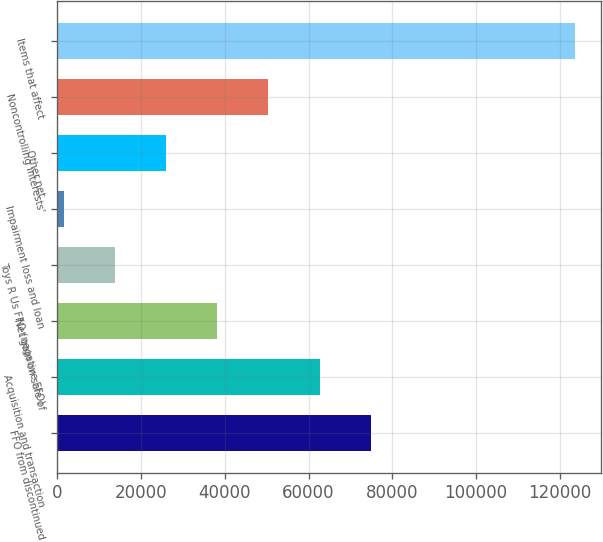Convert chart to OTSL. <chart><loc_0><loc_0><loc_500><loc_500><bar_chart><fcel>FFO from discontinued<fcel>Acquisition and transaction<fcel>Net gain on sale of<fcel>Toys R Us FFO (negative FFO)<fcel>Impairment loss and loan<fcel>Other net<fcel>Noncontrolling interests'<fcel>Items that affect<nl><fcel>74864.4<fcel>62645.5<fcel>38207.7<fcel>13769.9<fcel>1551<fcel>25988.8<fcel>50426.6<fcel>123740<nl></chart> 